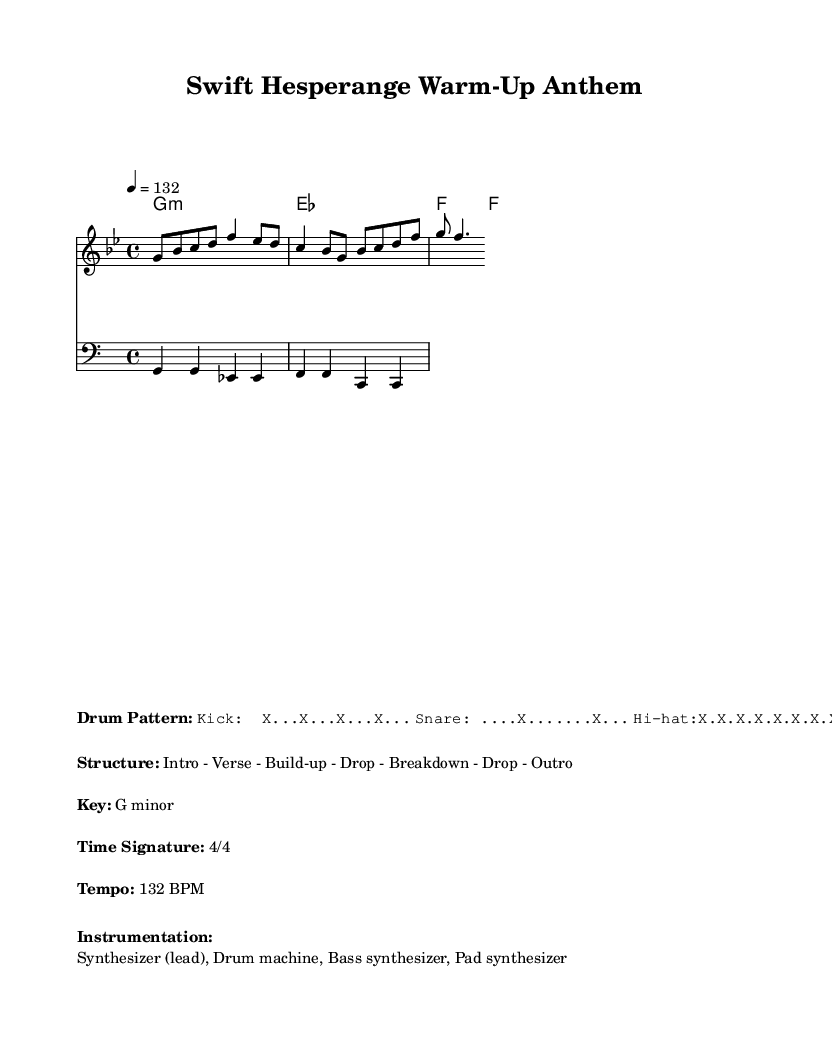What is the key signature of this music? The key signature is indicated at the beginning of the sheet music and shows that it is in G minor, which has two flats.
Answer: G minor What is the time signature of the music? The time signature is shown at the beginning of the sheet music; it is 4/4, meaning there are four beats in each measure and the quarter note gets one beat.
Answer: 4/4 What is the tempo of this music? The tempo is specified in the markup section, denoted with a BPM (beats per minute) value. The specific mark is 132 BPM, indicating how fast the music should be played.
Answer: 132 BPM What is the instrumentation used in this piece? The instrumentation is listed in the markup section, specifying the instruments involved in the piece. Here, it mentions a synthesizer (lead), drum machine, bass synthesizer, and pad synthesizer.
Answer: Synthesizer (lead), Drum machine, Bass synthesizer, Pad synthesizer What is the structure of the music? The structure is mentioned in the markup section, outlining the different sections of the song in order. It specifies an Intro followed by Verse, Build-up, Drop, Breakdown, another Drop, and finally an Outro.
Answer: Intro - Verse - Build-up - Drop - Breakdown - Drop - Outro How many different chords are used in the harmony? The harmony indicates that there are three distinct chords: G minor, E flat major, and F major. Counting these gives a total of three unique chords used throughout the piece.
Answer: 3 